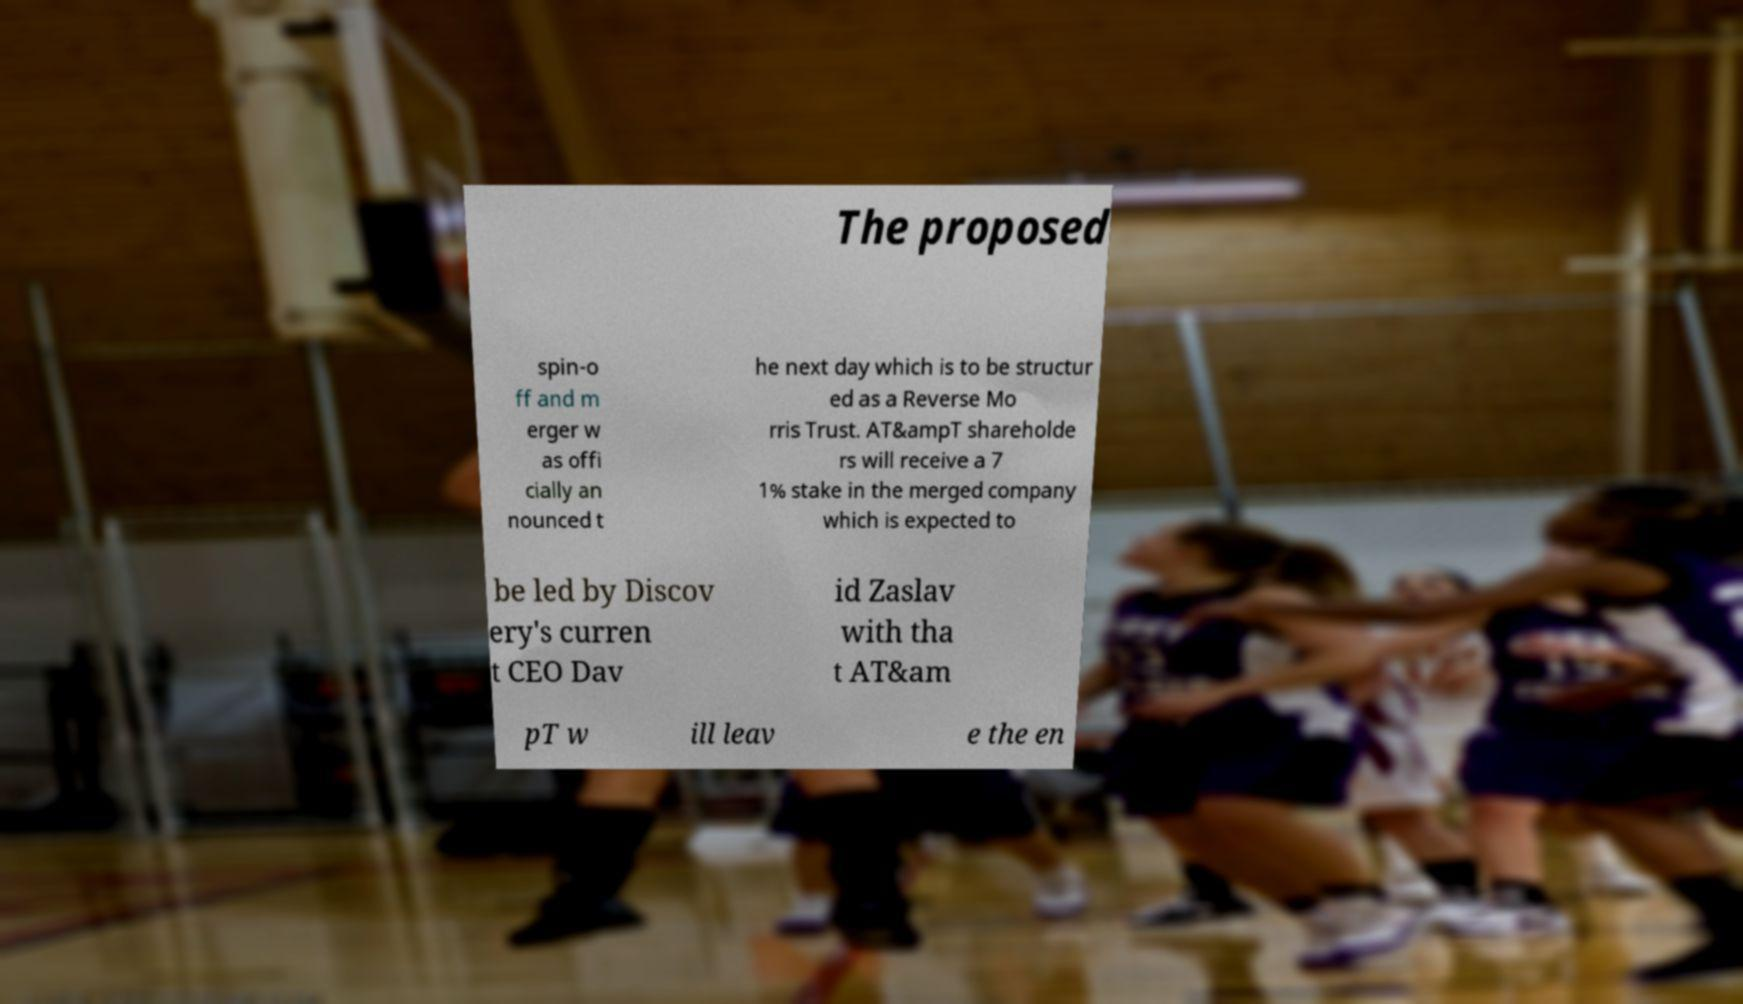There's text embedded in this image that I need extracted. Can you transcribe it verbatim? The proposed spin-o ff and m erger w as offi cially an nounced t he next day which is to be structur ed as a Reverse Mo rris Trust. AT&ampT shareholde rs will receive a 7 1% stake in the merged company which is expected to be led by Discov ery's curren t CEO Dav id Zaslav with tha t AT&am pT w ill leav e the en 